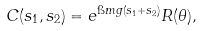<formula> <loc_0><loc_0><loc_500><loc_500>C ( s _ { 1 } , s _ { 2 } ) = e ^ { \i m g ( s _ { 1 } + s _ { 2 } ) } R ( \theta ) ,</formula> 